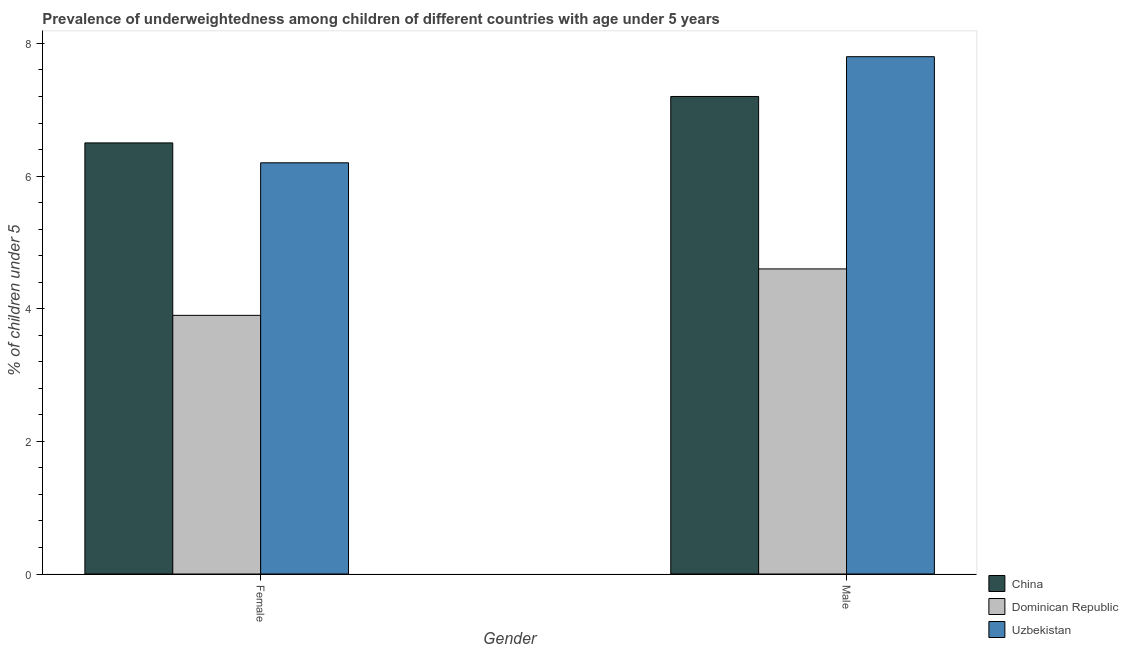How many groups of bars are there?
Your response must be concise. 2. Are the number of bars on each tick of the X-axis equal?
Your answer should be very brief. Yes. How many bars are there on the 1st tick from the right?
Ensure brevity in your answer.  3. What is the label of the 2nd group of bars from the left?
Your answer should be compact. Male. What is the percentage of underweighted female children in Dominican Republic?
Your answer should be very brief. 3.9. Across all countries, what is the maximum percentage of underweighted female children?
Your answer should be very brief. 6.5. Across all countries, what is the minimum percentage of underweighted male children?
Ensure brevity in your answer.  4.6. In which country was the percentage of underweighted male children maximum?
Your response must be concise. Uzbekistan. In which country was the percentage of underweighted female children minimum?
Keep it short and to the point. Dominican Republic. What is the total percentage of underweighted female children in the graph?
Your answer should be very brief. 16.6. What is the difference between the percentage of underweighted female children in Dominican Republic and that in Uzbekistan?
Provide a succinct answer. -2.3. What is the difference between the percentage of underweighted female children in Uzbekistan and the percentage of underweighted male children in China?
Ensure brevity in your answer.  -1. What is the average percentage of underweighted female children per country?
Ensure brevity in your answer.  5.53. What is the difference between the percentage of underweighted male children and percentage of underweighted female children in Dominican Republic?
Provide a succinct answer. 0.7. What is the ratio of the percentage of underweighted male children in China to that in Dominican Republic?
Ensure brevity in your answer.  1.57. In how many countries, is the percentage of underweighted male children greater than the average percentage of underweighted male children taken over all countries?
Keep it short and to the point. 2. What does the 2nd bar from the left in Female represents?
Offer a very short reply. Dominican Republic. Are all the bars in the graph horizontal?
Your response must be concise. No. How many countries are there in the graph?
Keep it short and to the point. 3. Are the values on the major ticks of Y-axis written in scientific E-notation?
Ensure brevity in your answer.  No. How many legend labels are there?
Your answer should be very brief. 3. How are the legend labels stacked?
Offer a very short reply. Vertical. What is the title of the graph?
Keep it short and to the point. Prevalence of underweightedness among children of different countries with age under 5 years. What is the label or title of the Y-axis?
Your answer should be very brief.  % of children under 5. What is the  % of children under 5 of Dominican Republic in Female?
Your answer should be compact. 3.9. What is the  % of children under 5 of Uzbekistan in Female?
Offer a terse response. 6.2. What is the  % of children under 5 in China in Male?
Offer a very short reply. 7.2. What is the  % of children under 5 in Dominican Republic in Male?
Your answer should be very brief. 4.6. What is the  % of children under 5 of Uzbekistan in Male?
Offer a terse response. 7.8. Across all Gender, what is the maximum  % of children under 5 of China?
Keep it short and to the point. 7.2. Across all Gender, what is the maximum  % of children under 5 of Dominican Republic?
Provide a short and direct response. 4.6. Across all Gender, what is the maximum  % of children under 5 in Uzbekistan?
Offer a very short reply. 7.8. Across all Gender, what is the minimum  % of children under 5 in Dominican Republic?
Ensure brevity in your answer.  3.9. Across all Gender, what is the minimum  % of children under 5 in Uzbekistan?
Your answer should be compact. 6.2. What is the total  % of children under 5 in China in the graph?
Provide a short and direct response. 13.7. What is the difference between the  % of children under 5 of China in Female and that in Male?
Give a very brief answer. -0.7. What is the difference between the  % of children under 5 of Dominican Republic in Female and that in Male?
Provide a succinct answer. -0.7. What is the difference between the  % of children under 5 of Uzbekistan in Female and that in Male?
Give a very brief answer. -1.6. What is the difference between the  % of children under 5 in China in Female and the  % of children under 5 in Dominican Republic in Male?
Keep it short and to the point. 1.9. What is the difference between the  % of children under 5 of China in Female and the  % of children under 5 of Uzbekistan in Male?
Give a very brief answer. -1.3. What is the difference between the  % of children under 5 of Dominican Republic in Female and the  % of children under 5 of Uzbekistan in Male?
Your response must be concise. -3.9. What is the average  % of children under 5 in China per Gender?
Your answer should be very brief. 6.85. What is the average  % of children under 5 of Dominican Republic per Gender?
Ensure brevity in your answer.  4.25. What is the difference between the  % of children under 5 of China and  % of children under 5 of Uzbekistan in Female?
Make the answer very short. 0.3. What is the difference between the  % of children under 5 of Dominican Republic and  % of children under 5 of Uzbekistan in Female?
Give a very brief answer. -2.3. What is the difference between the  % of children under 5 of China and  % of children under 5 of Dominican Republic in Male?
Give a very brief answer. 2.6. What is the difference between the  % of children under 5 in China and  % of children under 5 in Uzbekistan in Male?
Make the answer very short. -0.6. What is the difference between the  % of children under 5 of Dominican Republic and  % of children under 5 of Uzbekistan in Male?
Ensure brevity in your answer.  -3.2. What is the ratio of the  % of children under 5 in China in Female to that in Male?
Ensure brevity in your answer.  0.9. What is the ratio of the  % of children under 5 in Dominican Republic in Female to that in Male?
Make the answer very short. 0.85. What is the ratio of the  % of children under 5 in Uzbekistan in Female to that in Male?
Offer a very short reply. 0.79. What is the difference between the highest and the second highest  % of children under 5 in Uzbekistan?
Provide a short and direct response. 1.6. 